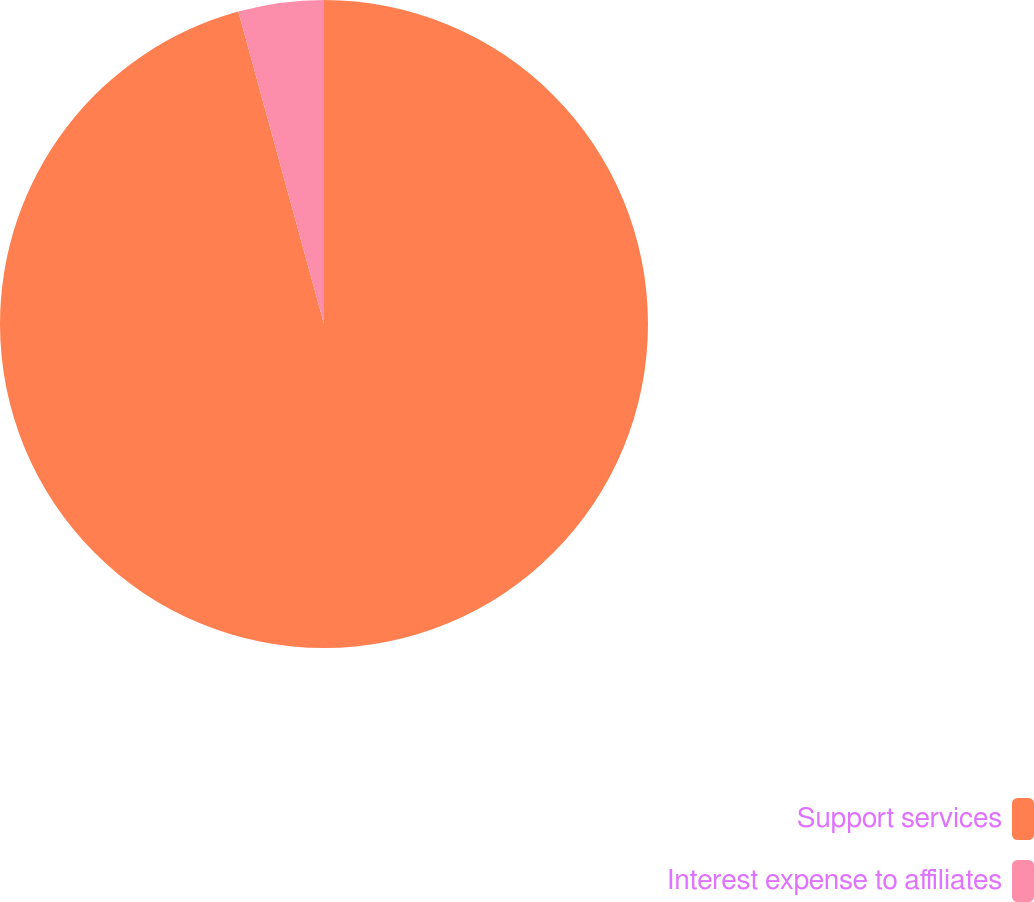Convert chart. <chart><loc_0><loc_0><loc_500><loc_500><pie_chart><fcel>Support services<fcel>Interest expense to affiliates<nl><fcel>95.74%<fcel>4.26%<nl></chart> 